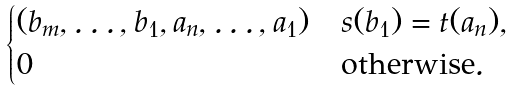Convert formula to latex. <formula><loc_0><loc_0><loc_500><loc_500>\begin{cases} ( b _ { m } , \dots , b _ { 1 } , a _ { n } , \dots , a _ { 1 } ) & s ( b _ { 1 } ) = t ( a _ { n } ) , \\ 0 & \text {otherwise} . \end{cases}</formula> 